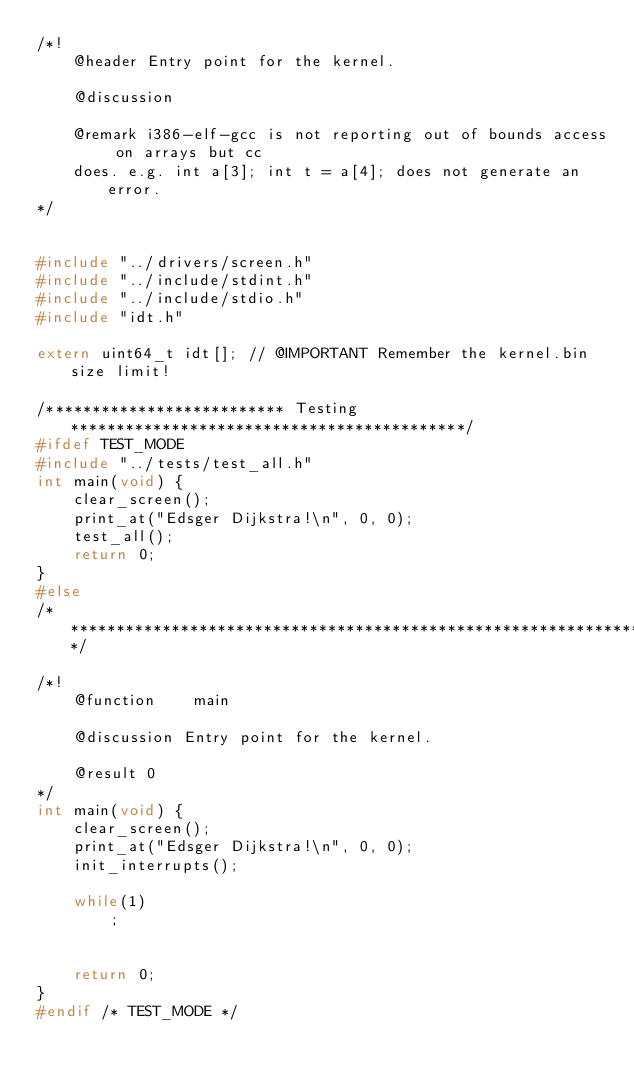<code> <loc_0><loc_0><loc_500><loc_500><_C_>/*!
    @header Entry point for the kernel.

    @discussion

    @remark i386-elf-gcc is not reporting out of bounds access on arrays but cc
    does. e.g. int a[3]; int t = a[4]; does not generate an error.
*/


#include "../drivers/screen.h"
#include "../include/stdint.h"
#include "../include/stdio.h"
#include "idt.h"

extern uint64_t idt[]; // @IMPORTANT Remember the kernel.bin size limit!

/************************** Testing *******************************************/
#ifdef TEST_MODE
#include "../tests/test_all.h"
int main(void) {
    clear_screen();
    print_at("Edsger Dijkstra!\n", 0, 0);
    test_all();
    return 0;
}
#else
/******************************************************************************/

/*!
    @function    main

    @discussion Entry point for the kernel.

    @result 0
*/
int main(void) {
    clear_screen();
    print_at("Edsger Dijkstra!\n", 0, 0);
    init_interrupts();

    while(1)
        ;


    return 0;
}
#endif /* TEST_MODE */</code> 